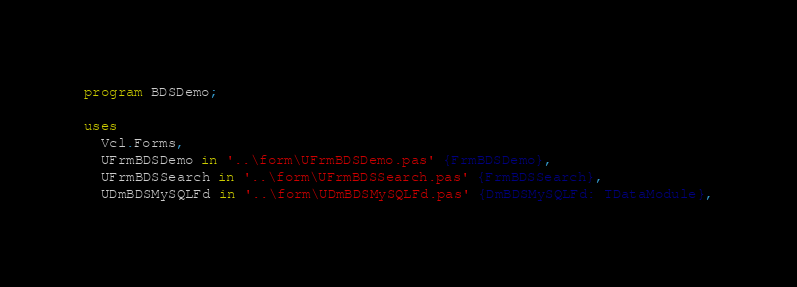<code> <loc_0><loc_0><loc_500><loc_500><_Pascal_>program BDSDemo;

uses
  Vcl.Forms,
  UFrmBDSDemo in '..\form\UFrmBDSDemo.pas' {FrmBDSDemo},
  UFrmBDSSearch in '..\form\UFrmBDSSearch.pas' {FrmBDSSearch},
  UDmBDSMySQLFd in '..\form\UDmBDSMySQLFd.pas' {DmBDSMySQLFd: TDataModule},</code> 